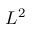Convert formula to latex. <formula><loc_0><loc_0><loc_500><loc_500>L ^ { 2 }</formula> 